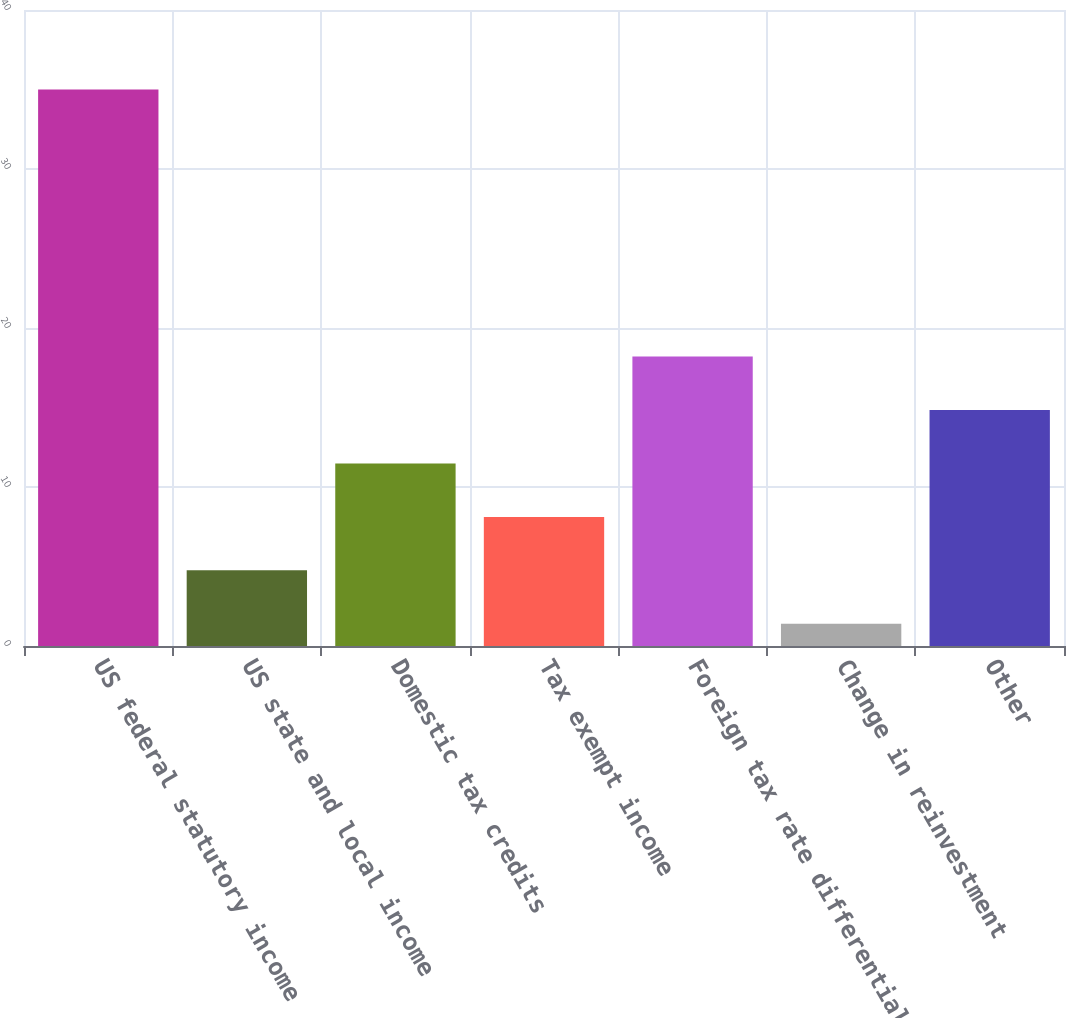<chart> <loc_0><loc_0><loc_500><loc_500><bar_chart><fcel>US federal statutory income<fcel>US state and local income<fcel>Domestic tax credits<fcel>Tax exempt income<fcel>Foreign tax rate differential<fcel>Change in reinvestment<fcel>Other<nl><fcel>35<fcel>4.76<fcel>11.48<fcel>8.12<fcel>18.2<fcel>1.4<fcel>14.84<nl></chart> 